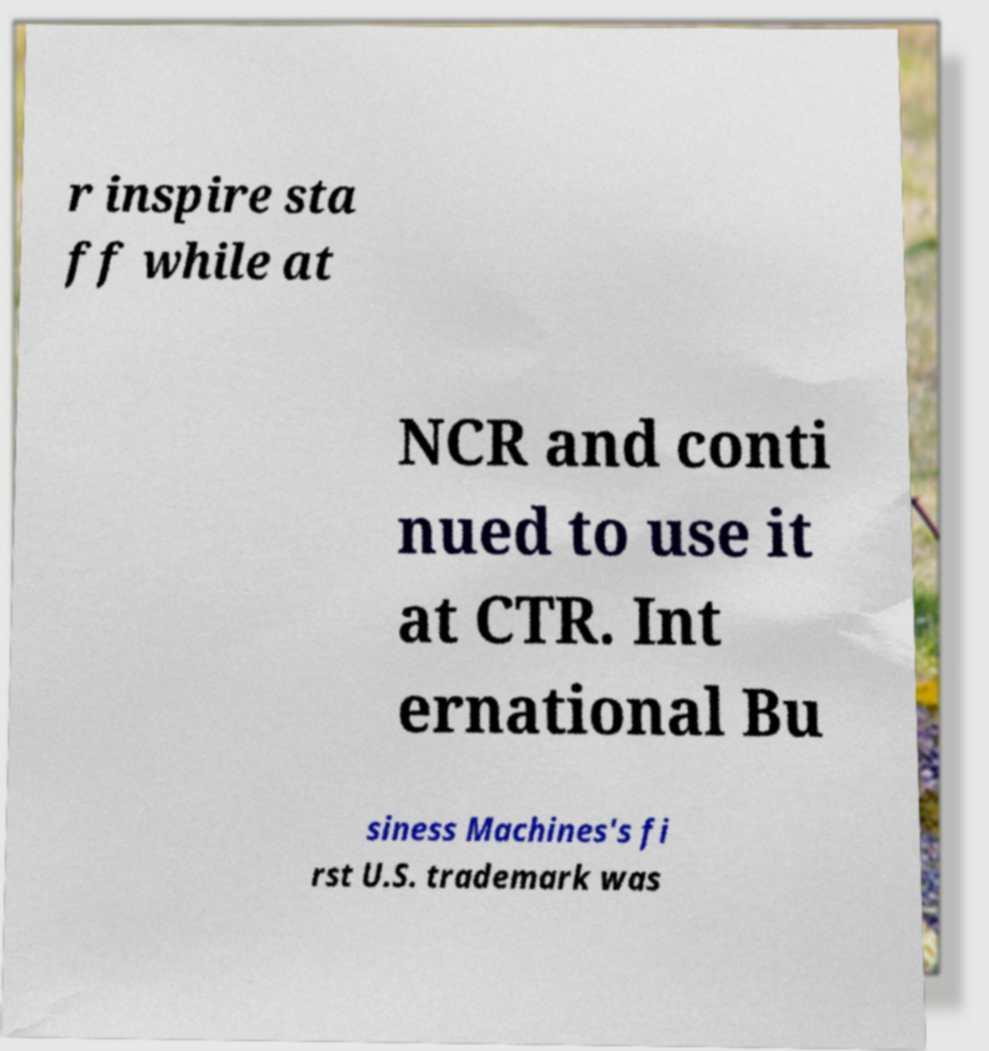Can you read and provide the text displayed in the image?This photo seems to have some interesting text. Can you extract and type it out for me? r inspire sta ff while at NCR and conti nued to use it at CTR. Int ernational Bu siness Machines's fi rst U.S. trademark was 